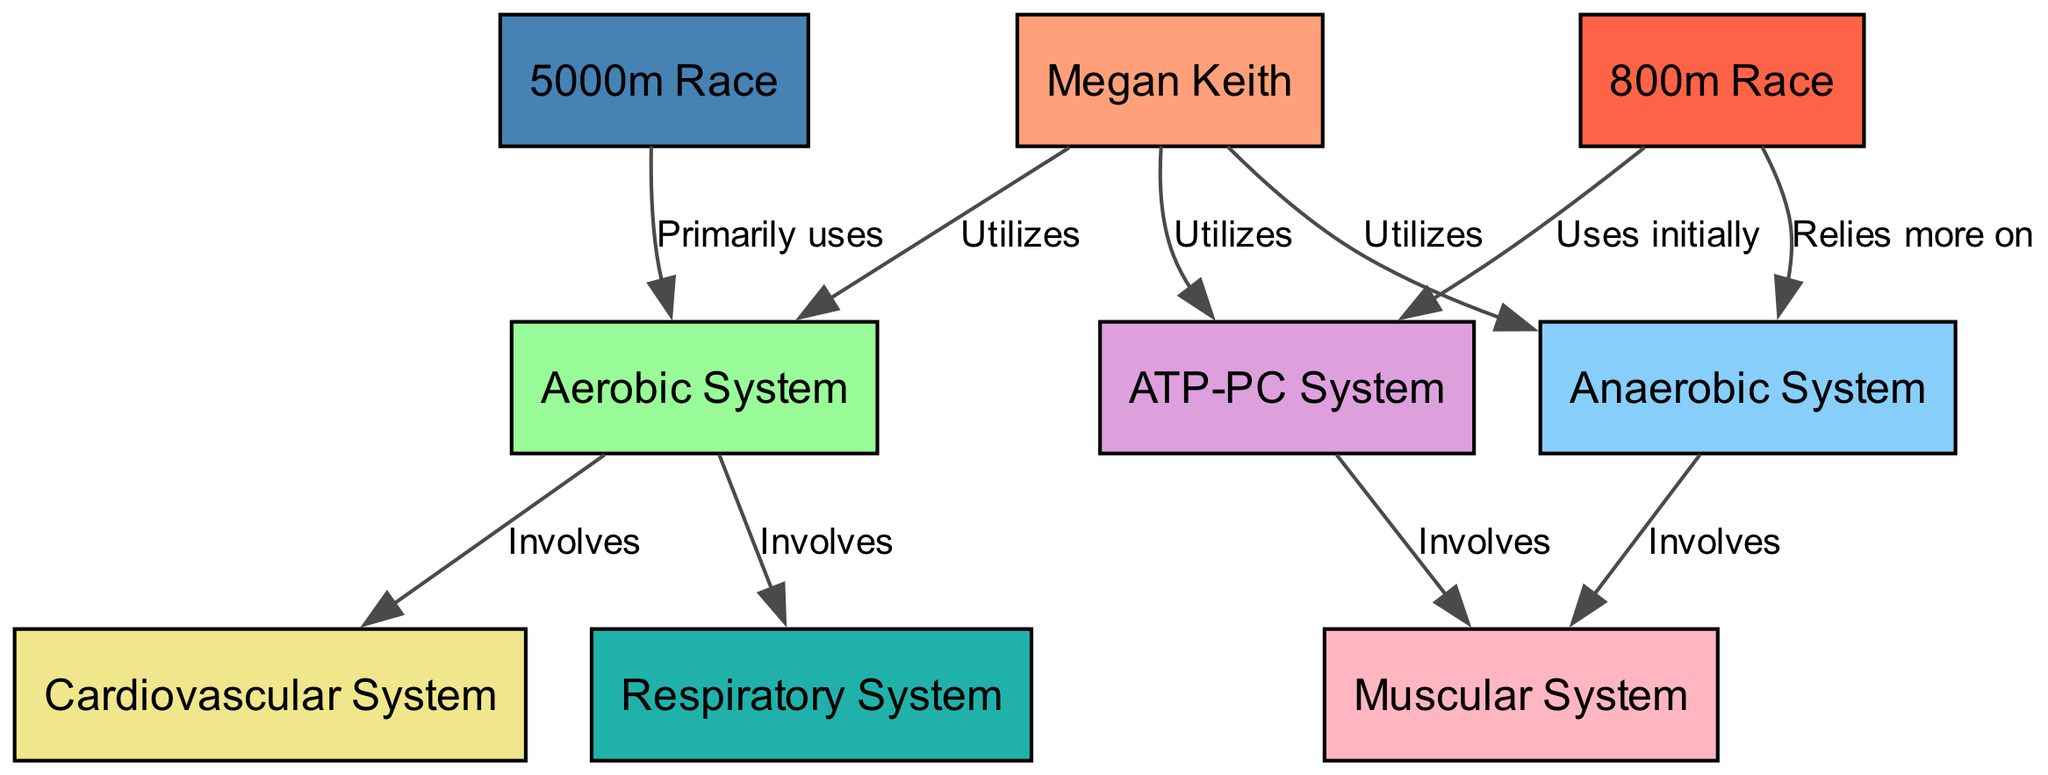What is the primary energy system Megan Keith utilizes during a 5000m race? The diagram shows that Megan Keith primarily uses the Aerobic System during a 5000m race, as indicated by the edge labeled "Primarily uses" from the 5000m Race node to the Aerobic System node.
Answer: Aerobic System Which system involves the muscular system? The diagram indicates that both the Anaerobic System and the ATP-PC System involve the Muscular System, each represented by an edge labeled "Involves" leading to the Muscular System from those respective nodes.
Answer: Anaerobic System, ATP-PC System How many total nodes are present in the diagram? By counting the individual nodes listed in the data, we find there are 9 nodes in total, representing various systems and race distances related to Megan Keith.
Answer: 9 Which system does the 800m race primarily rely on? The diagram illustrates that the 800m Race relies more on the Anaerobic System, as shown by the edge labeled "Relies more on" leading from the 800m Race node to the Anaerobic System node.
Answer: Anaerobic System What two systems are involved in the cardiovascular process? The diagram shows that both the Aerobic System and the Respiratory System are involved with connections labeled "Involves" from the Aerobic System node to both the Cardiovascular and Respiratory System nodes respectively.
Answer: Cardiovascular System, Respiratory System Which system does Megan Keith utilize at the start of an 800m race? According to the diagram, Megan Keith initially utilizes the ATP-PC System at the start of an 800m race, as indicated by the edge labeled "Uses initially" from the 800m Race node to the ATP-PC System node.
Answer: ATP-PC System What is the common element between the 5000m race and the Aerobic System? The common element is that the 5000m race primarily uses the Aerobic System, as depicted by the connection labeled "Primarily uses" from the 5000m Race node to the Aerobic System node.
Answer: Aerobic System How many edges connect the Aerobic System to other systems in the diagram? The diagram demonstrates that there are two edges connecting the Aerobic System; these are directed towards the Cardiovascular System and the Respiratory System, indicating their involvement in aerobic processing.
Answer: 2 